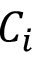Convert formula to latex. <formula><loc_0><loc_0><loc_500><loc_500>C _ { i }</formula> 